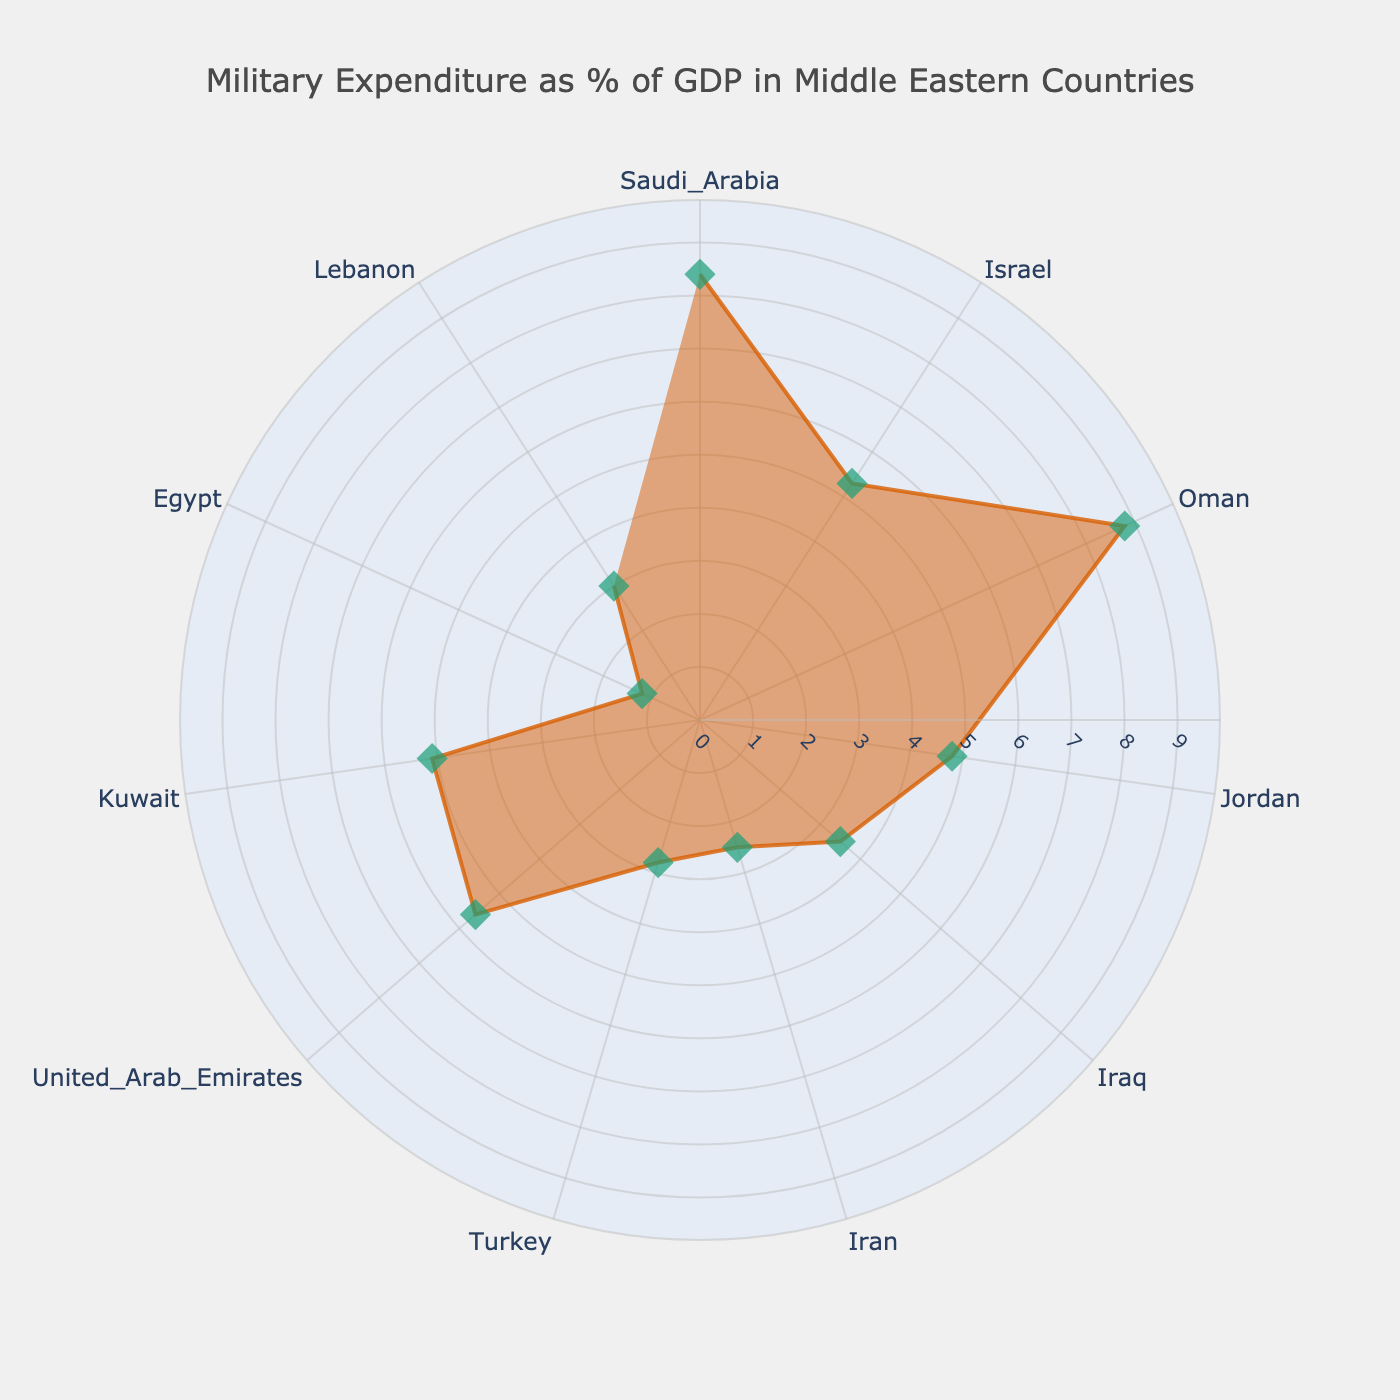what is the title of the figure? The title is clearly visible at the top of the chart.
Answer: Military Expenditure as % of GDP in Middle Eastern Countries Which country has the highest military expenditure as a percentage of GDP? By locating the country with the maximum radial value on the plot, we find that the highest value is associated with a specific country.
Answer: Oman How does the military expenditure percentage of Iran compare to Turkey? By comparing the radial distances associated with Iran and Turkey, it is observed that Iran's value is lower.
Answer: Iran's is lower What is the approximate range of military expenditure percentages among these countries? Find the lowest and highest radial values from the chart, then subtract the lowest from the highest. The highest value is 8.8 and the lowest is 1.2.
Answer: 7.6 What are the countries with military expenditure higher than 5% of GDP? Identify the countries where the radial values exceed 5%. These are shown more outward from the central point.
Answer: Saudi Arabia, Oman, Israel, United Arab Emirates, Kuwait Which country ranks right in the middle if you order the countries by their military expenditure as a percentage of GDP? Count the total number of countries (11) and identify the country at the 6th position when ordered by the radial value (middle value).
Answer: Kuwait Estimate the difference in military expenditure as a percentage of GDP between the highest and lowest spending countries. The highest value is 8.8 (Oman) and the lowest is 1.2 (Egypt). Subtract the lowest from the highest.
Answer: 7.6 Are there any countries that have very close (almost equal) military expenditure percentages? Look for countries with similar radial distances. Compare the values nearby to see if they are similar.
Answer: Israel (5.3) and Kuwait (5.1) What is the average military expenditure as a percentage of GDP for all the countries listed? Sum all the percentages and then divide by the number of countries. (8.4 + 5.3 + 8.8 + 4.8 + 3.5 + 2.5 + 2.8 + 5.6 + 5.1 + 1.2 + 3.0) / 11.
Answer: 4.6 Which countries have military expenditures above the regional average? Calculate the average percentage and then identify the countries with values above this average (4.6%).
Answer: Saudi Arabia, Oman, Israel, United Arab Emirates, Kuwait 